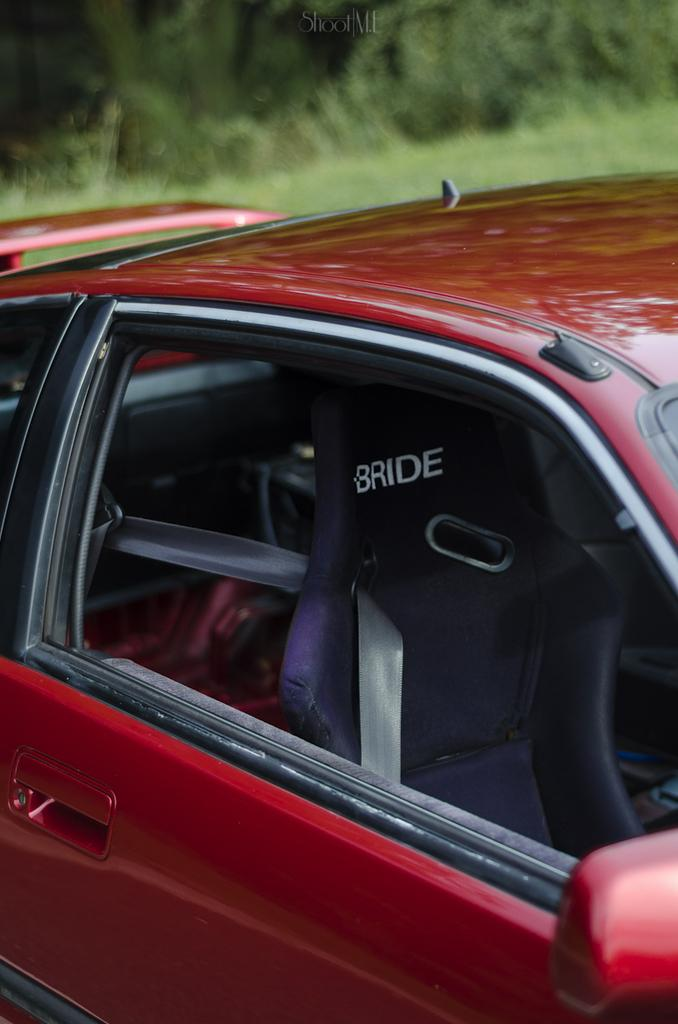What is the main subject of the image? There is a car in the image. Can you describe the color of the car? The car is dark red in color. What else can be seen in the image besides the car? There are plants visible at the top of the image. What type of guitar is being played by the arch in the image? There is no guitar or arch present in the image; it only features a car and plants. 